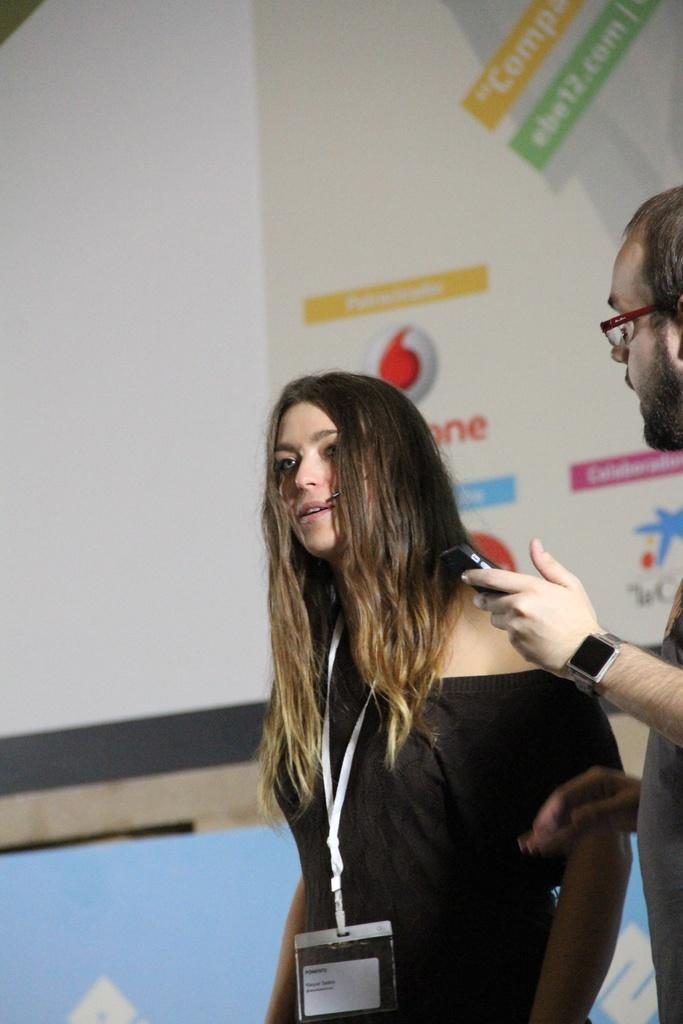Could you give a brief overview of what you see in this image? In this image, there are a few people. In the background, we can see some boards with text and images. 